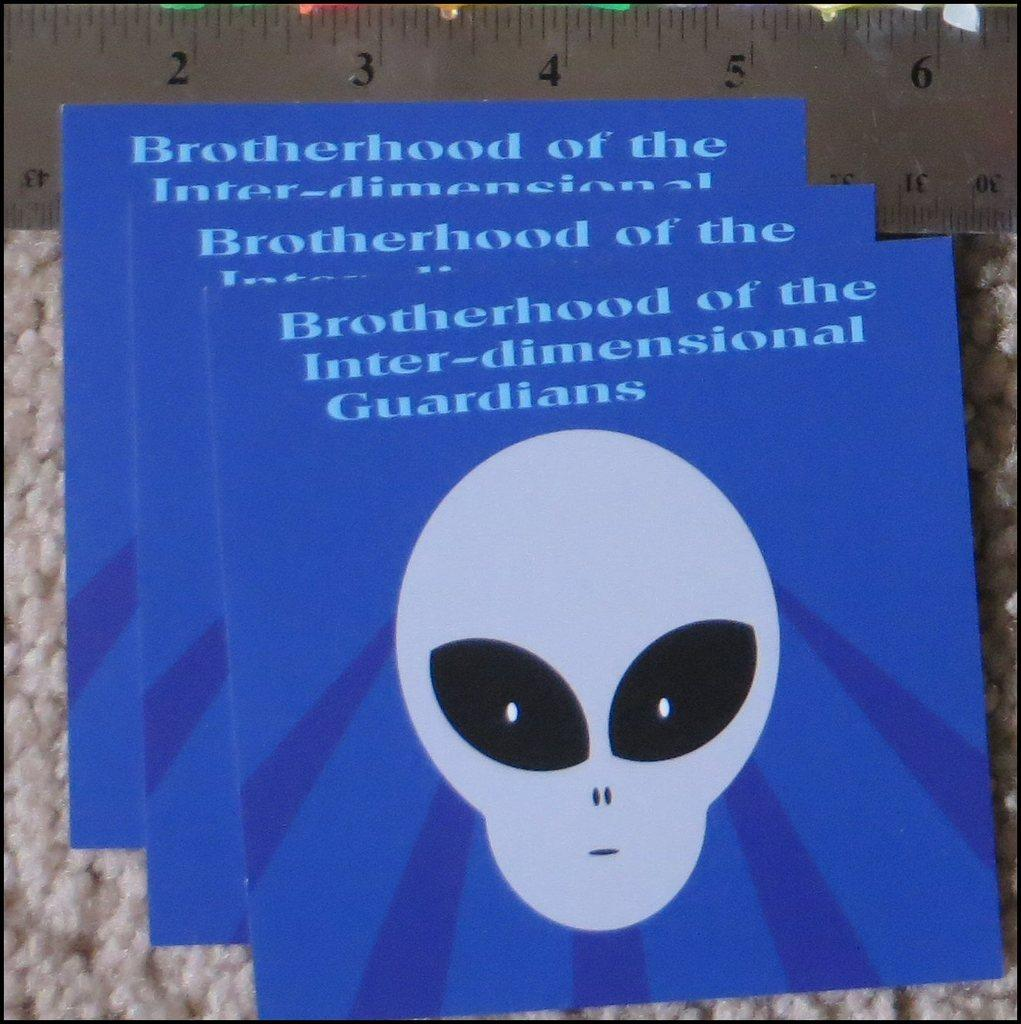What color are the boards in the image? The boards in the image are blue. What is written on the blue boards? There is text written on the blue boards. What type of flooring is present in the image? There is a white color carpet in the image. What tool is visible at the top of the image? There is a measuring scale visible at the top of the image. How does the earthquake affect the blue boards in the image? There is no earthquake present in the image, so its effect on the blue boards cannot be determined. 